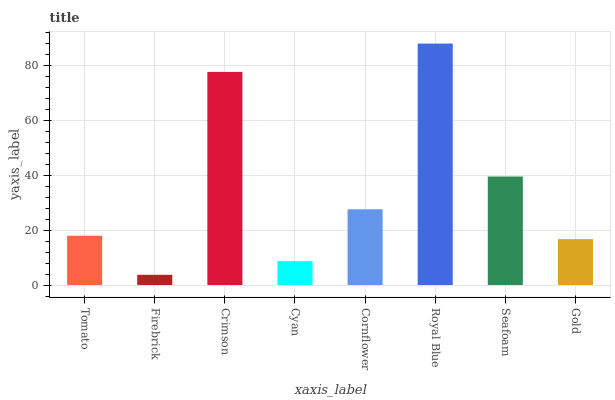Is Firebrick the minimum?
Answer yes or no. Yes. Is Royal Blue the maximum?
Answer yes or no. Yes. Is Crimson the minimum?
Answer yes or no. No. Is Crimson the maximum?
Answer yes or no. No. Is Crimson greater than Firebrick?
Answer yes or no. Yes. Is Firebrick less than Crimson?
Answer yes or no. Yes. Is Firebrick greater than Crimson?
Answer yes or no. No. Is Crimson less than Firebrick?
Answer yes or no. No. Is Cornflower the high median?
Answer yes or no. Yes. Is Tomato the low median?
Answer yes or no. Yes. Is Cyan the high median?
Answer yes or no. No. Is Crimson the low median?
Answer yes or no. No. 